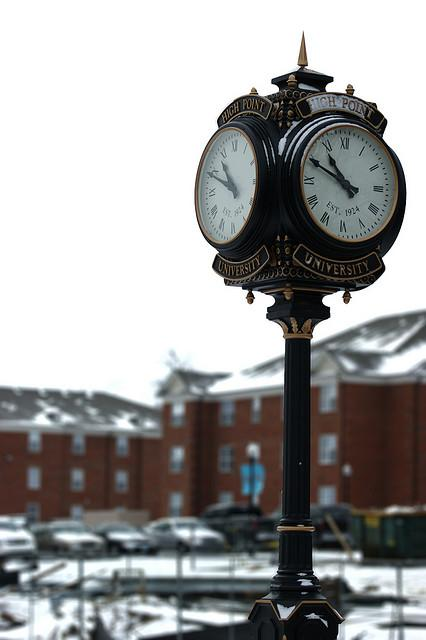This University is affiliated with what denomination?

Choices:
A) baptist
B) lutheran
C) mormon
D) methodist methodist 